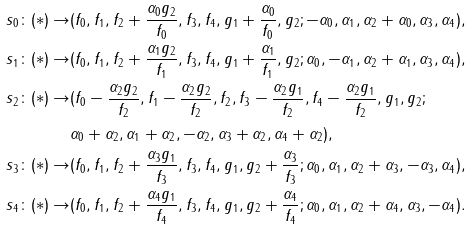Convert formula to latex. <formula><loc_0><loc_0><loc_500><loc_500>s _ { 0 } \colon ( * ) \rightarrow & ( f _ { 0 } , f _ { 1 } , f _ { 2 } + \frac { \alpha _ { 0 } g _ { 2 } } { f _ { 0 } } , f _ { 3 } , f _ { 4 } , g _ { 1 } + \frac { \alpha _ { 0 } } { f _ { 0 } } , g _ { 2 } ; - \alpha _ { 0 } , \alpha _ { 1 } , \alpha _ { 2 } + \alpha _ { 0 } , \alpha _ { 3 } , \alpha _ { 4 } ) , \\ s _ { 1 } \colon ( * ) \rightarrow & ( f _ { 0 } , f _ { 1 } , f _ { 2 } + \frac { \alpha _ { 1 } g _ { 2 } } { f _ { 1 } } , f _ { 3 } , f _ { 4 } , g _ { 1 } + \frac { \alpha _ { 1 } } { f _ { 1 } } , g _ { 2 } ; \alpha _ { 0 } , - \alpha _ { 1 } , \alpha _ { 2 } + \alpha _ { 1 } , \alpha _ { 3 } , \alpha _ { 4 } ) , \\ s _ { 2 } \colon ( * ) \rightarrow & ( f _ { 0 } - \frac { \alpha _ { 2 } g _ { 2 } } { f _ { 2 } } , f _ { 1 } - \frac { \alpha _ { 2 } g _ { 2 } } { f _ { 2 } } , f _ { 2 } , f _ { 3 } - \frac { \alpha _ { 2 } g _ { 1 } } { f _ { 2 } } , f _ { 4 } - \frac { \alpha _ { 2 } g _ { 1 } } { f _ { 2 } } , g _ { 1 } , g _ { 2 } ; \\ & \alpha _ { 0 } + \alpha _ { 2 } , \alpha _ { 1 } + \alpha _ { 2 } , - \alpha _ { 2 } , \alpha _ { 3 } + \alpha _ { 2 } , \alpha _ { 4 } + \alpha _ { 2 } ) , \\ s _ { 3 } \colon ( * ) \rightarrow & ( f _ { 0 } , f _ { 1 } , f _ { 2 } + \frac { \alpha _ { 3 } g _ { 1 } } { f _ { 3 } } , f _ { 3 } , f _ { 4 } , g _ { 1 } , g _ { 2 } + \frac { \alpha _ { 3 } } { f _ { 3 } } ; \alpha _ { 0 } , \alpha _ { 1 } , \alpha _ { 2 } + \alpha _ { 3 } , - \alpha _ { 3 } , \alpha _ { 4 } ) , \\ s _ { 4 } \colon ( * ) \rightarrow & ( f _ { 0 } , f _ { 1 } , f _ { 2 } + \frac { \alpha _ { 4 } g _ { 1 } } { f _ { 4 } } , f _ { 3 } , f _ { 4 } , g _ { 1 } , g _ { 2 } + \frac { \alpha _ { 4 } } { f _ { 4 } } ; \alpha _ { 0 } , \alpha _ { 1 } , \alpha _ { 2 } + \alpha _ { 4 } , \alpha _ { 3 } , - \alpha _ { 4 } ) .</formula> 